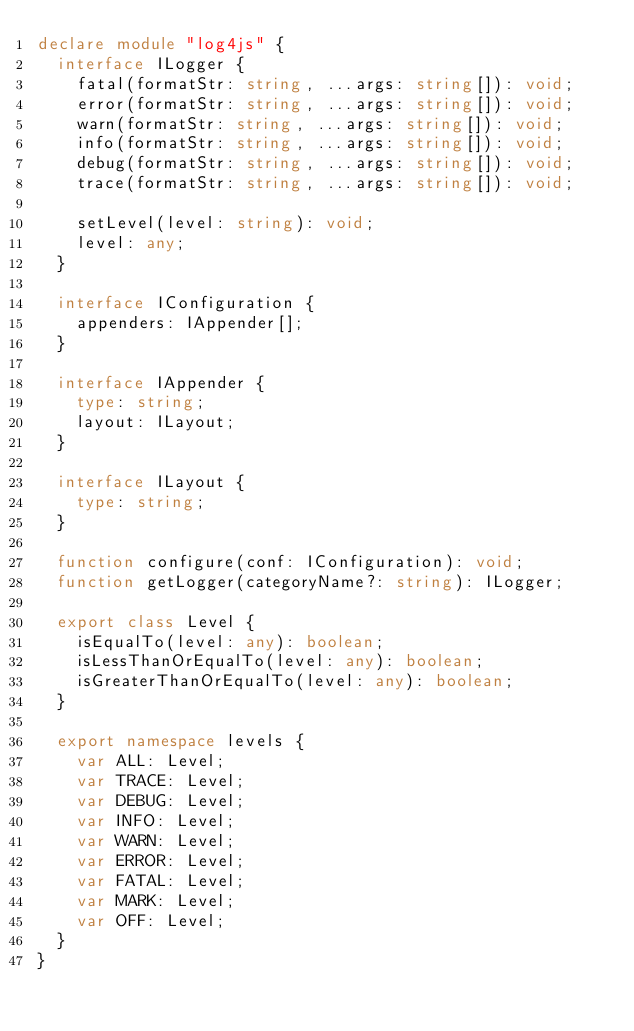Convert code to text. <code><loc_0><loc_0><loc_500><loc_500><_TypeScript_>declare module "log4js" {
	interface ILogger {
		fatal(formatStr: string, ...args: string[]): void;
		error(formatStr: string, ...args: string[]): void;
		warn(formatStr: string, ...args: string[]): void;
		info(formatStr: string, ...args: string[]): void;
		debug(formatStr: string, ...args: string[]): void;
		trace(formatStr: string, ...args: string[]): void;

		setLevel(level: string): void;
		level: any;
	}

	interface IConfiguration {
		appenders: IAppender[];
	}

	interface IAppender {
		type: string;
		layout: ILayout;
	}

	interface ILayout {
		type: string;
	}

	function configure(conf: IConfiguration): void;
	function getLogger(categoryName?: string): ILogger;

	export class Level {
		isEqualTo(level: any): boolean;
		isLessThanOrEqualTo(level: any): boolean;
		isGreaterThanOrEqualTo(level: any): boolean;
	}

	export namespace levels {
		var ALL: Level;
		var TRACE: Level;
		var DEBUG: Level;
		var INFO: Level;
		var WARN: Level;
		var ERROR: Level;
		var FATAL: Level;
		var MARK: Level;
		var OFF: Level;
	}
}
</code> 